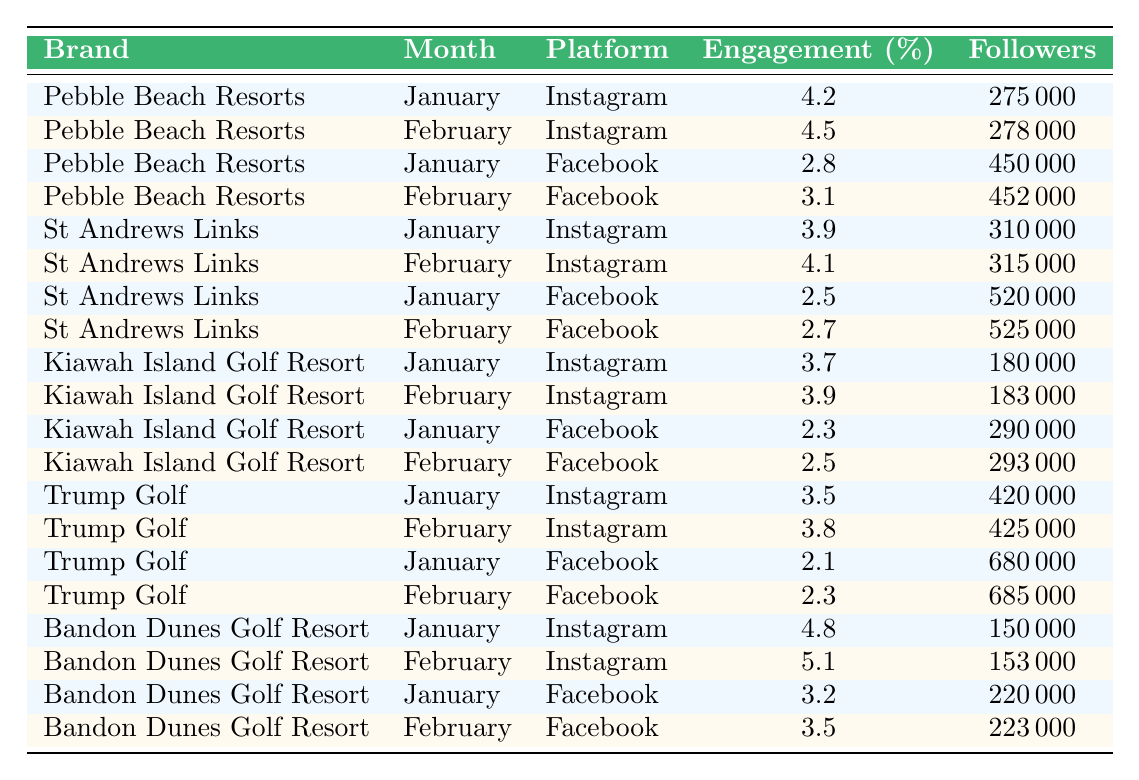What's the engagement rate for Pebble Beach Resorts on Instagram in February? The table shows that Pebble Beach Resorts has an engagement rate of 4.5% on Instagram for the month of February.
Answer: 4.5% Which platform had a higher engagement rate for St Andrews Links in January? In January, St Andrews Links had an engagement rate of 3.9% on Instagram and 2.5% on Facebook. Since 3.9% is greater than 2.5%, Instagram has the higher engagement rate.
Answer: Instagram What is the total number of followers for Trump Golf on Facebook in February? The table states that Trump Golf had 685,000 followers on Facebook in February.
Answer: 685000 Which brand had the highest engagement rate on Instagram in February? Looking at the engagement rates on Instagram for February, Bandon Dunes Golf Resort had the highest rate at 5.1%.
Answer: Bandon Dunes Golf Resort What was the average engagement rate for Kiawah Island Golf Resort across both platforms in January? For Kiawah Island Golf Resort in January, the engagement rates are 3.7% on Instagram and 2.3% on Facebook. The average is calculated as (3.7 + 2.3) / 2 = 3.0%.
Answer: 3.0% Is the engagement rate for Bandon Dunes Golf Resort on Instagram always higher than on Facebook? In January, the engagement rate for Instagram was 4.8%, and for Facebook, it was 3.2%. In February, Instagram was 5.1% and Facebook was 3.5%. Since Instagram always has a higher rate, the answer is yes.
Answer: Yes Which brand improved its engagement rate on Facebook from January to February? Upon examining the table, Pebble Beach Resorts improved from 2.8% to 3.1%, while others either stayed the same or declined.
Answer: Pebble Beach Resorts What is the difference in engagement rates for Instagram between Bandon Dunes Golf Resort and Trump Golf in February? Bandon Dunes had an engagement rate of 5.1%, while Trump Golf had 3.8%. The difference is 5.1% - 3.8% = 1.3%.
Answer: 1.3% Which brand's total followers on Instagram in February is greater than 250,000? Pebble Beach Resorts (278,000), St Andrews Links (315,000), and Bandon Dunes Golf Resort (153,000) all have more than 250,000 followers in February.
Answer: Pebble Beach Resorts, St Andrews Links What was the lowest engagement rate for Kiawah Island Golf Resort across both platforms? Kiawah Island Golf Resort had an engagement rate of 2.3% on Facebook in January, which is the lowest compared to other rates.
Answer: 2.3% 